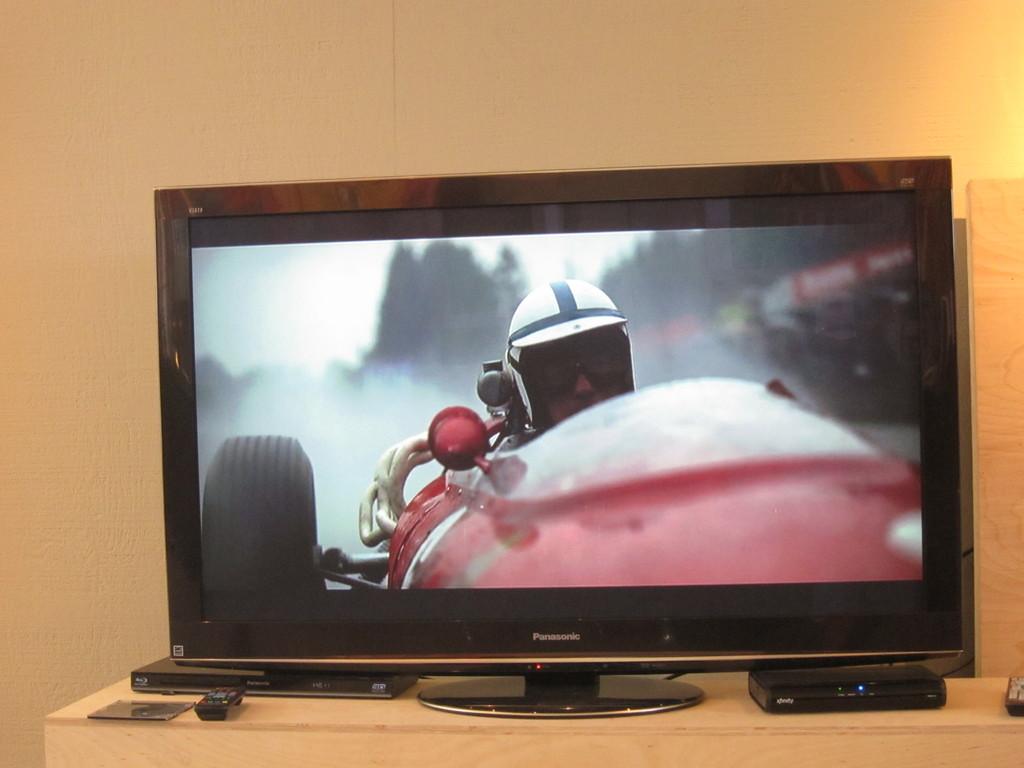What brand of television is this?
Make the answer very short. Panasonic. What cable provider is being used for this television?
Keep it short and to the point. Xfinity. 